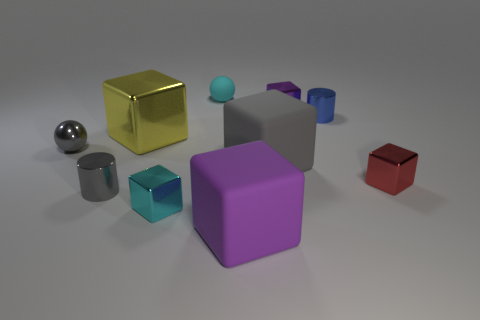What is the material of the cylinder that is on the right side of the purple metallic cube?
Offer a very short reply. Metal. Is the shape of the purple object that is in front of the blue cylinder the same as the purple thing that is behind the big shiny thing?
Make the answer very short. Yes. Is the number of gray cylinders that are behind the cyan matte ball the same as the number of gray cylinders?
Your answer should be compact. No. What number of large purple things are the same material as the yellow object?
Make the answer very short. 0. The other big block that is the same material as the gray block is what color?
Your answer should be very brief. Purple. There is a cyan shiny thing; is its size the same as the cylinder that is on the right side of the yellow shiny thing?
Keep it short and to the point. Yes. What is the shape of the small purple metal thing?
Your response must be concise. Cube. What number of tiny metallic blocks are the same color as the tiny matte object?
Give a very brief answer. 1. There is a small metal thing that is the same shape as the tiny cyan matte thing; what is its color?
Your response must be concise. Gray. How many large things are on the left side of the large matte cube in front of the red cube?
Offer a very short reply. 1. 